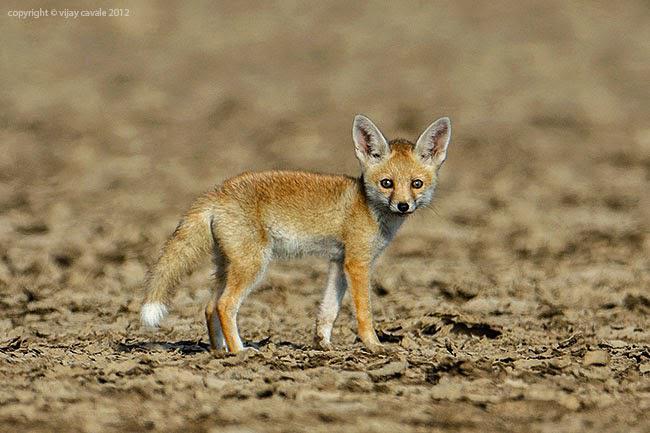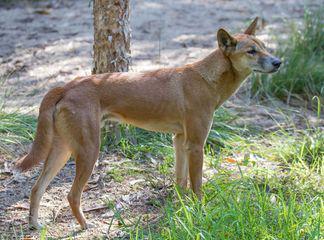The first image is the image on the left, the second image is the image on the right. For the images displayed, is the sentence "The fox in the image on the left is standing in a barren sandy area." factually correct? Answer yes or no. Yes. 